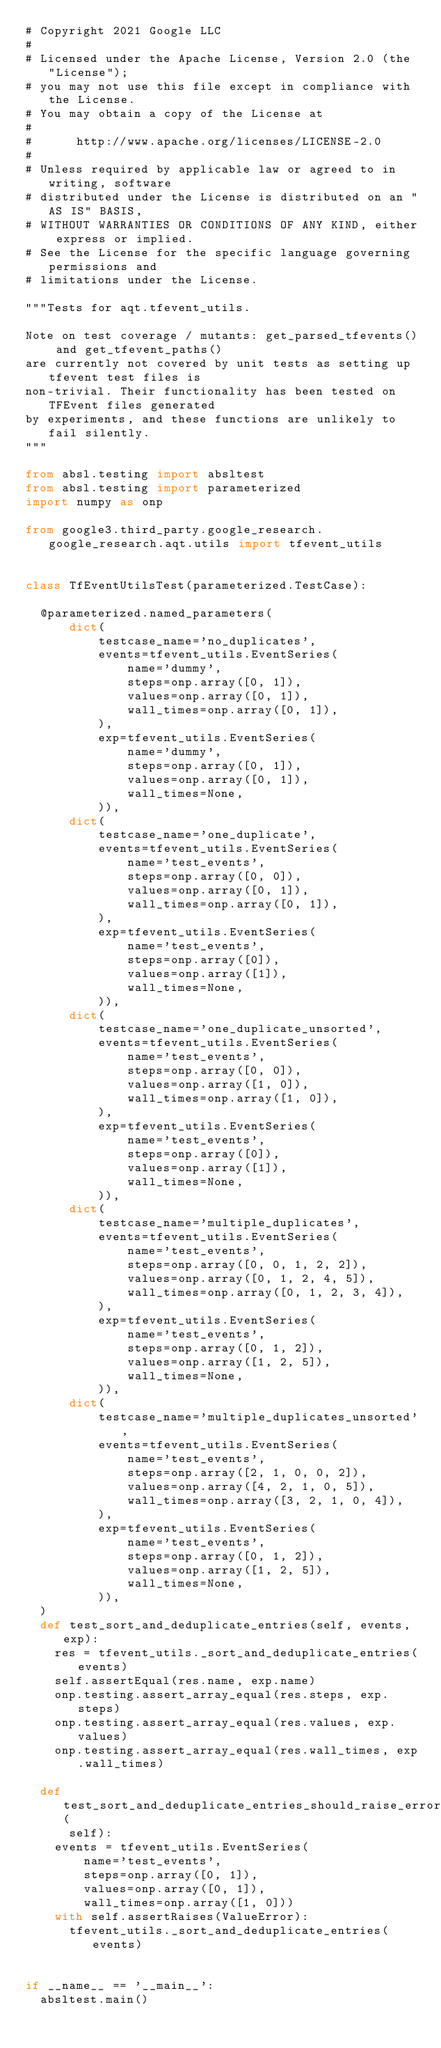<code> <loc_0><loc_0><loc_500><loc_500><_Python_># Copyright 2021 Google LLC
#
# Licensed under the Apache License, Version 2.0 (the "License");
# you may not use this file except in compliance with the License.
# You may obtain a copy of the License at
#
#      http://www.apache.org/licenses/LICENSE-2.0
#
# Unless required by applicable law or agreed to in writing, software
# distributed under the License is distributed on an "AS IS" BASIS,
# WITHOUT WARRANTIES OR CONDITIONS OF ANY KIND, either express or implied.
# See the License for the specific language governing permissions and
# limitations under the License.

"""Tests for aqt.tfevent_utils.

Note on test coverage / mutants: get_parsed_tfevents() and get_tfevent_paths()
are currently not covered by unit tests as setting up tfevent test files is
non-trivial. Their functionality has been tested on TFEvent files generated
by experiments, and these functions are unlikely to fail silently.
"""

from absl.testing import absltest
from absl.testing import parameterized
import numpy as onp

from google3.third_party.google_research.google_research.aqt.utils import tfevent_utils


class TfEventUtilsTest(parameterized.TestCase):

  @parameterized.named_parameters(
      dict(
          testcase_name='no_duplicates',
          events=tfevent_utils.EventSeries(
              name='dummy',
              steps=onp.array([0, 1]),
              values=onp.array([0, 1]),
              wall_times=onp.array([0, 1]),
          ),
          exp=tfevent_utils.EventSeries(
              name='dummy',
              steps=onp.array([0, 1]),
              values=onp.array([0, 1]),
              wall_times=None,
          )),
      dict(
          testcase_name='one_duplicate',
          events=tfevent_utils.EventSeries(
              name='test_events',
              steps=onp.array([0, 0]),
              values=onp.array([0, 1]),
              wall_times=onp.array([0, 1]),
          ),
          exp=tfevent_utils.EventSeries(
              name='test_events',
              steps=onp.array([0]),
              values=onp.array([1]),
              wall_times=None,
          )),
      dict(
          testcase_name='one_duplicate_unsorted',
          events=tfevent_utils.EventSeries(
              name='test_events',
              steps=onp.array([0, 0]),
              values=onp.array([1, 0]),
              wall_times=onp.array([1, 0]),
          ),
          exp=tfevent_utils.EventSeries(
              name='test_events',
              steps=onp.array([0]),
              values=onp.array([1]),
              wall_times=None,
          )),
      dict(
          testcase_name='multiple_duplicates',
          events=tfevent_utils.EventSeries(
              name='test_events',
              steps=onp.array([0, 0, 1, 2, 2]),
              values=onp.array([0, 1, 2, 4, 5]),
              wall_times=onp.array([0, 1, 2, 3, 4]),
          ),
          exp=tfevent_utils.EventSeries(
              name='test_events',
              steps=onp.array([0, 1, 2]),
              values=onp.array([1, 2, 5]),
              wall_times=None,
          )),
      dict(
          testcase_name='multiple_duplicates_unsorted',
          events=tfevent_utils.EventSeries(
              name='test_events',
              steps=onp.array([2, 1, 0, 0, 2]),
              values=onp.array([4, 2, 1, 0, 5]),
              wall_times=onp.array([3, 2, 1, 0, 4]),
          ),
          exp=tfevent_utils.EventSeries(
              name='test_events',
              steps=onp.array([0, 1, 2]),
              values=onp.array([1, 2, 5]),
              wall_times=None,
          )),
  )
  def test_sort_and_deduplicate_entries(self, events, exp):
    res = tfevent_utils._sort_and_deduplicate_entries(events)
    self.assertEqual(res.name, exp.name)
    onp.testing.assert_array_equal(res.steps, exp.steps)
    onp.testing.assert_array_equal(res.values, exp.values)
    onp.testing.assert_array_equal(res.wall_times, exp.wall_times)

  def test_sort_and_deduplicate_entries_should_raise_error_when_wall_times_unsorted(
      self):
    events = tfevent_utils.EventSeries(
        name='test_events',
        steps=onp.array([0, 1]),
        values=onp.array([0, 1]),
        wall_times=onp.array([1, 0]))
    with self.assertRaises(ValueError):
      tfevent_utils._sort_and_deduplicate_entries(events)


if __name__ == '__main__':
  absltest.main()
</code> 